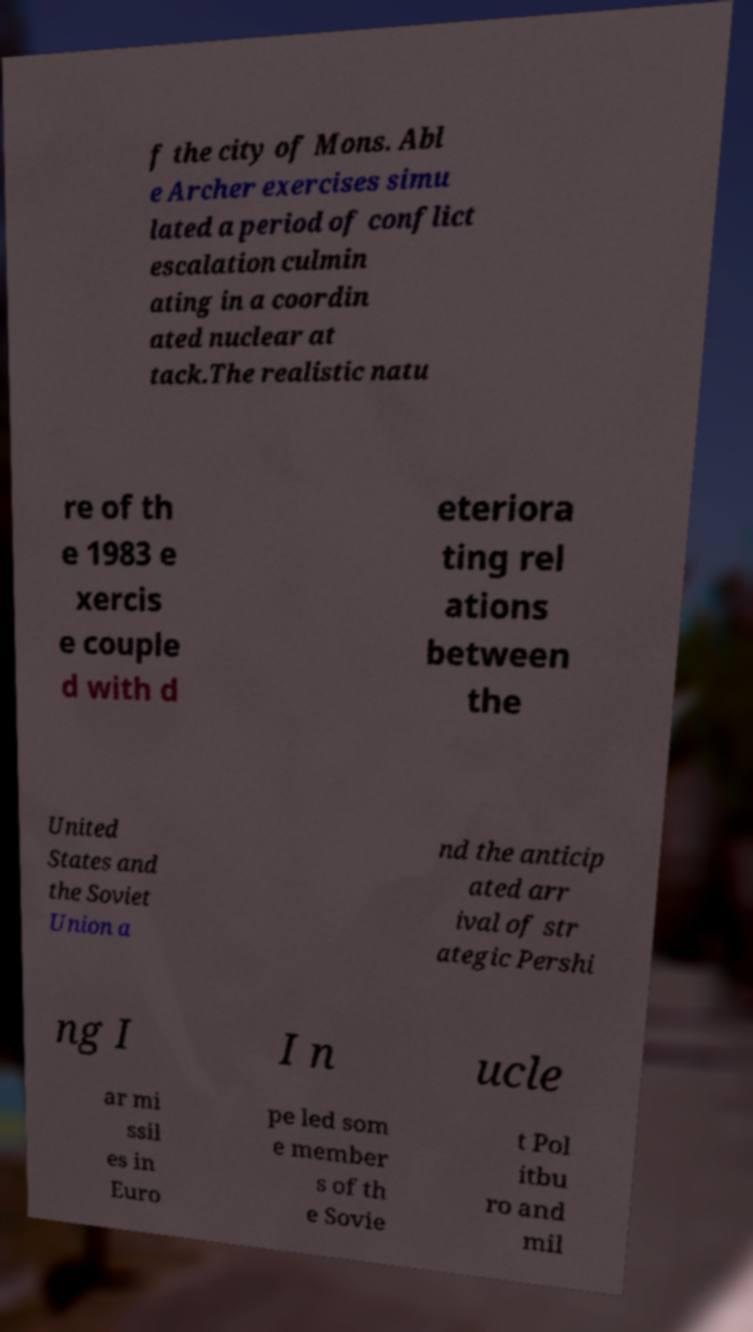There's text embedded in this image that I need extracted. Can you transcribe it verbatim? f the city of Mons. Abl e Archer exercises simu lated a period of conflict escalation culmin ating in a coordin ated nuclear at tack.The realistic natu re of th e 1983 e xercis e couple d with d eteriora ting rel ations between the United States and the Soviet Union a nd the anticip ated arr ival of str ategic Pershi ng I I n ucle ar mi ssil es in Euro pe led som e member s of th e Sovie t Pol itbu ro and mil 